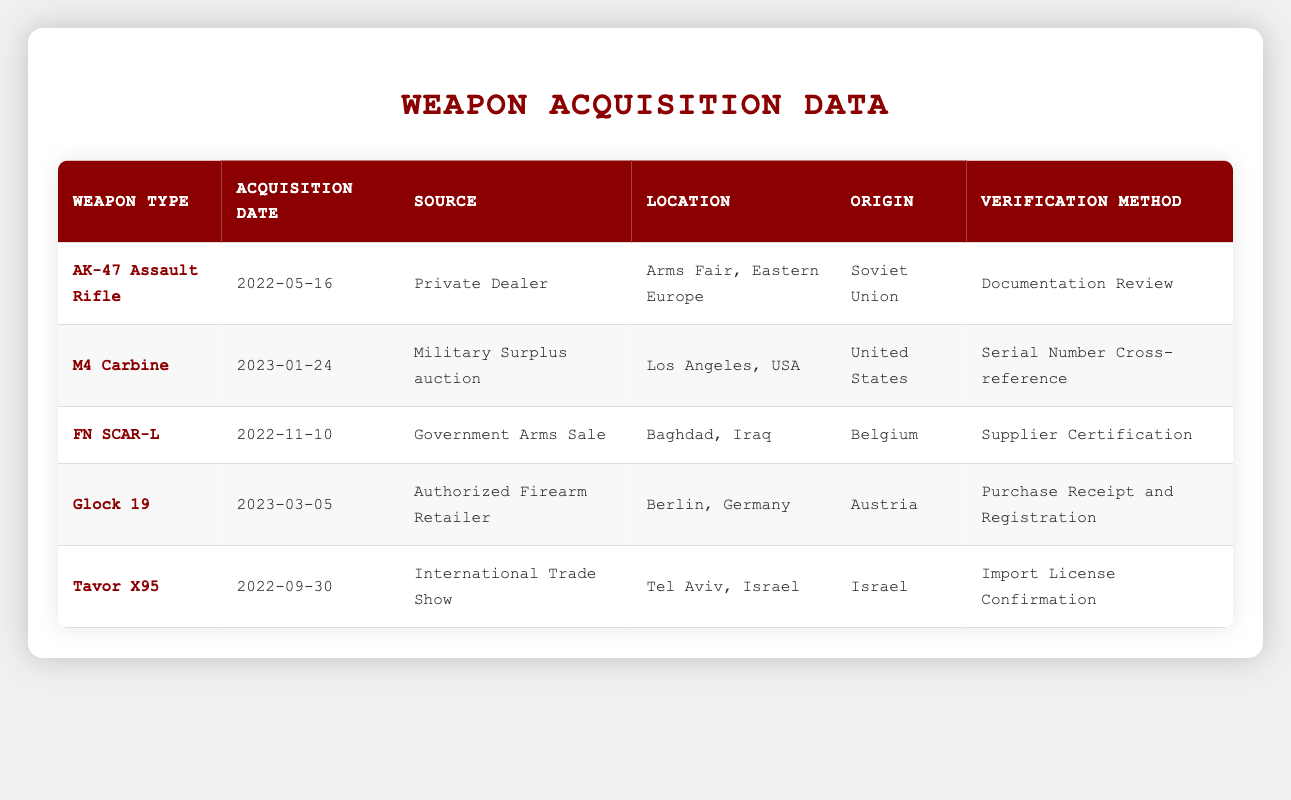What is the acquisition date for the Glock 19? The table lists the Glock 19 under the "Weapon Type" column, and the corresponding "Acquisition Date" for this weapon is found in the same row, which is 2023-03-05.
Answer: 2023-03-05 Which weapon was acquired from a Government Arms Sale? Looking through the "Source" column in the table, the FN SCAR-L is the only weapon listed with "Government Arms Sale" as the source.
Answer: FN SCAR-L Is the AK-47 sourced from a dealer in Eastern Europe? The AK-47's source is specified as "Private Dealer" and its location indicates it was acquired from "Arms Fair, Eastern Europe." Therefore, it confirms that the AK-47 is sourced from a dealer in Eastern Europe.
Answer: Yes What is the origin of the Tavor X95? By examining the "Origin" column for the Tavor X95, it is recorded as "Israel," which directly provides the answer.
Answer: Israel How many weapons were acquired in 2022? By reviewing the "Acquisition Date" column, we find three weapons with dates in 2022 (AK-47, FN SCAR-L, Tavor X95). Therefore, when counting these entries, we arrive at a total of three weapons acquired that year.
Answer: 3 Which verification method was used for the M4 Carbine? Each weapon's "Verification Method" can be located in their respective rows, and for the M4 Carbine, it is "Serial Number Cross-reference."
Answer: Serial Number Cross-reference Was any weapon acquired in Berlin, Germany? The table shows that the Glock 19 was acquired in Berlin, Germany, as indicated in the "Location" column, confirming a weapon was indeed acquired there.
Answer: Yes What is the total number of different weapon types listed in the table? Counting the unique entries in the "Weapon Type" column, there are five distinct types (AK-47, M4 Carbine, FN SCAR-L, Glock 19, Tavor X95), resulting in a total of five different weapon types.
Answer: 5 Which weapon acquired in 2023 is from the United States? Reviewing the "Acquisition Date" for 2023 and the "Origin" indicates that the M4 Carbine, acquired on 2023-01-24, has its origin attributed to the United States.
Answer: M4 Carbine 